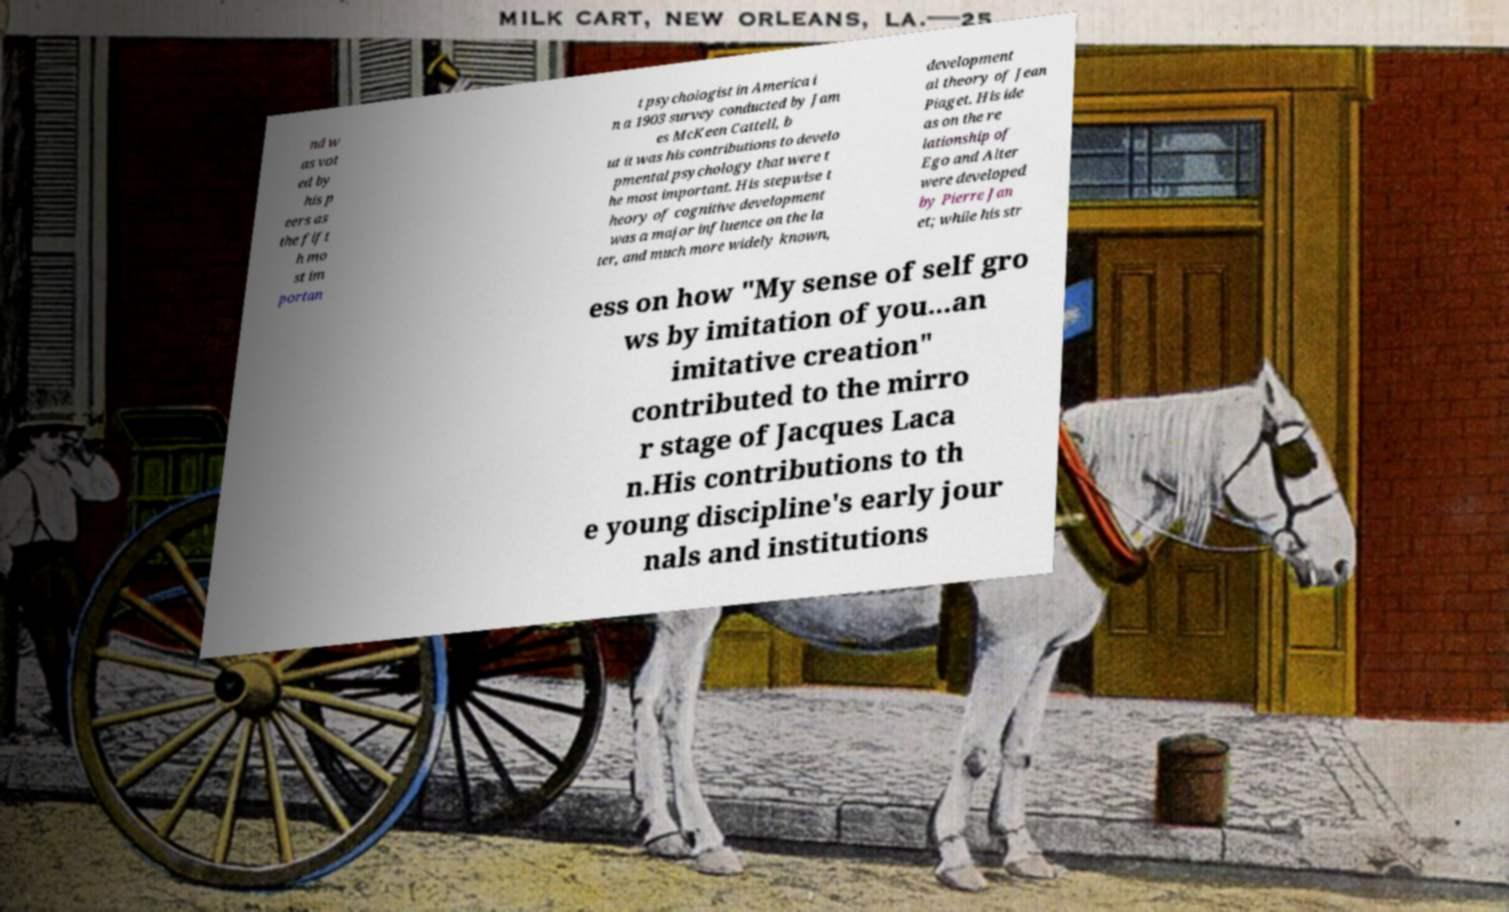Please read and relay the text visible in this image. What does it say? nd w as vot ed by his p eers as the fift h mo st im portan t psychologist in America i n a 1903 survey conducted by Jam es McKeen Cattell, b ut it was his contributions to develo pmental psychology that were t he most important. His stepwise t heory of cognitive development was a major influence on the la ter, and much more widely known, development al theory of Jean Piaget. His ide as on the re lationship of Ego and Alter were developed by Pierre Jan et; while his str ess on how "My sense of self gro ws by imitation of you...an imitative creation" contributed to the mirro r stage of Jacques Laca n.His contributions to th e young discipline's early jour nals and institutions 